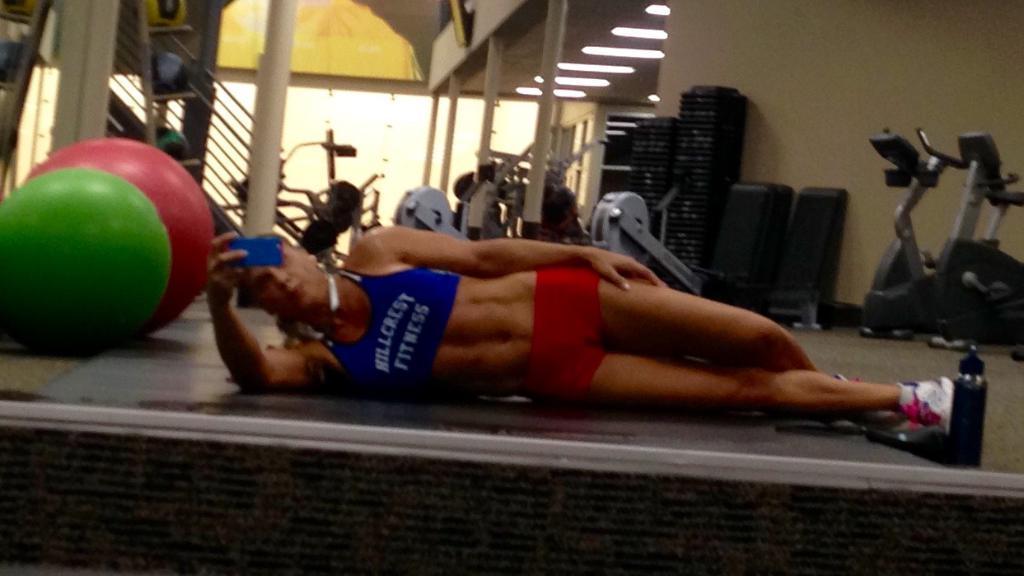Describe this image in one or two sentences. In this picture there is a person laying on the floor and holding a mobile. We can see balls, gym equipment, railing and pillars. In the background of the image we can see lights and wall. 